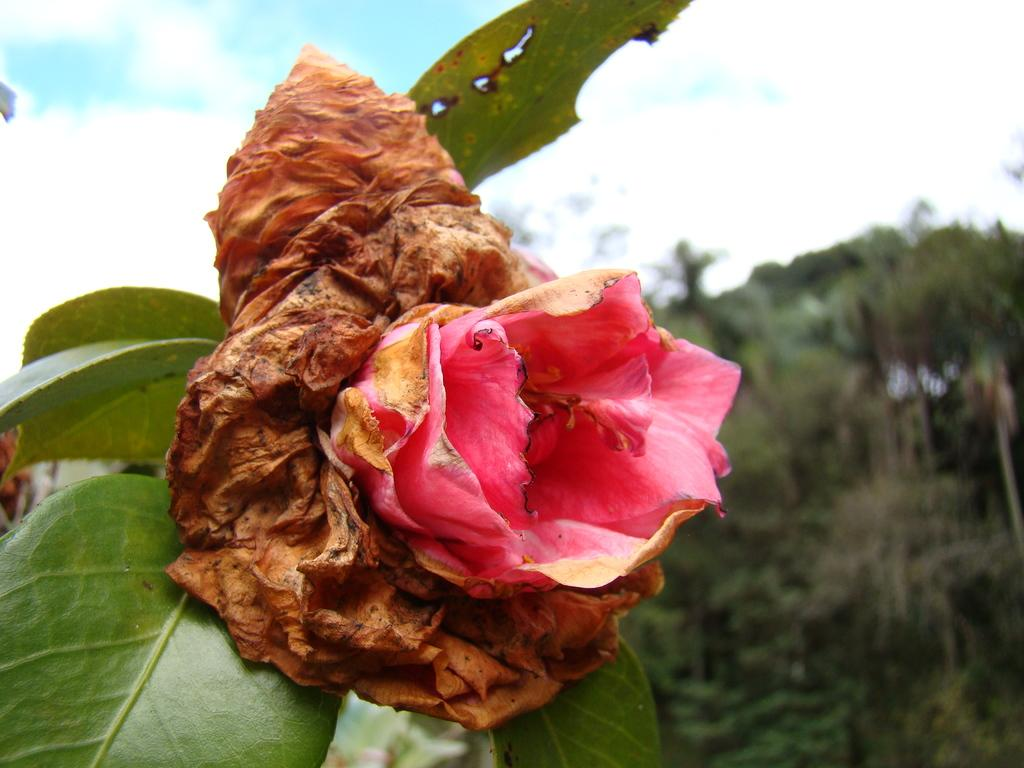What is the main subject of the image? There is a flower in the image. Can you describe the color of the flower? The flower is pink in color. What can be seen in the background of the image? There are trees and the sky visible in the background of the image. How many goldfish are swimming in the cellar in the image? There are no goldfish or cellars present in the image; it features a pink flower with trees and the sky in the background. 